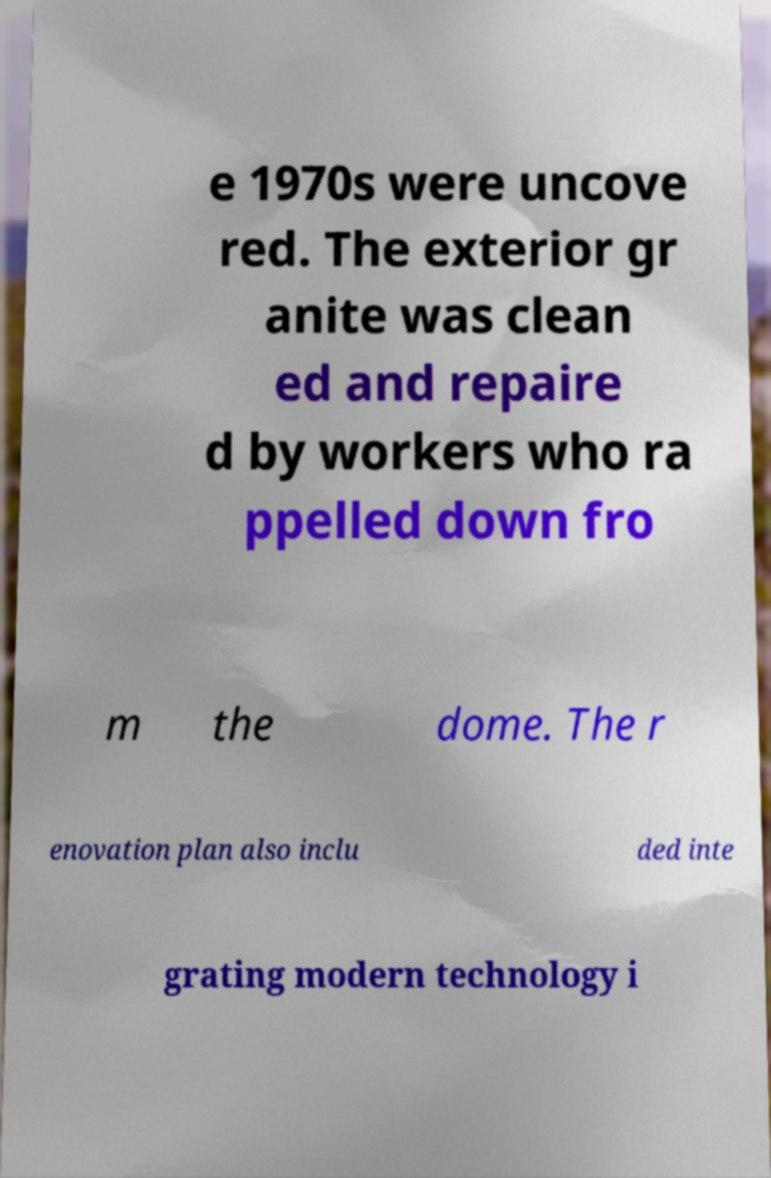Please identify and transcribe the text found in this image. e 1970s were uncove red. The exterior gr anite was clean ed and repaire d by workers who ra ppelled down fro m the dome. The r enovation plan also inclu ded inte grating modern technology i 